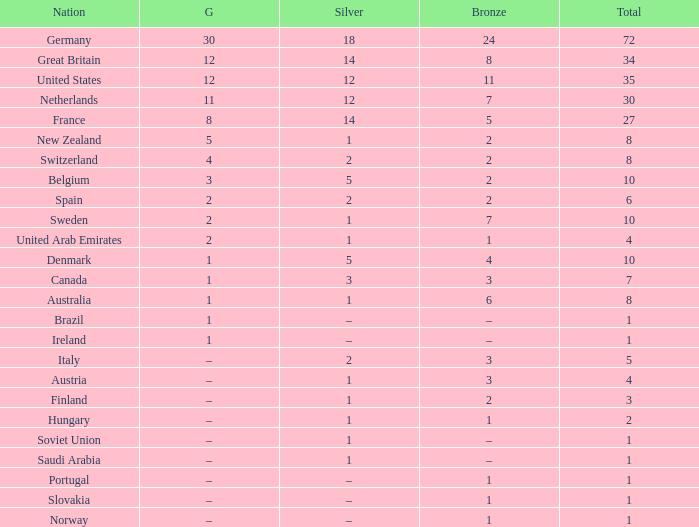What is Gold, when Total is 6? 2.0. 